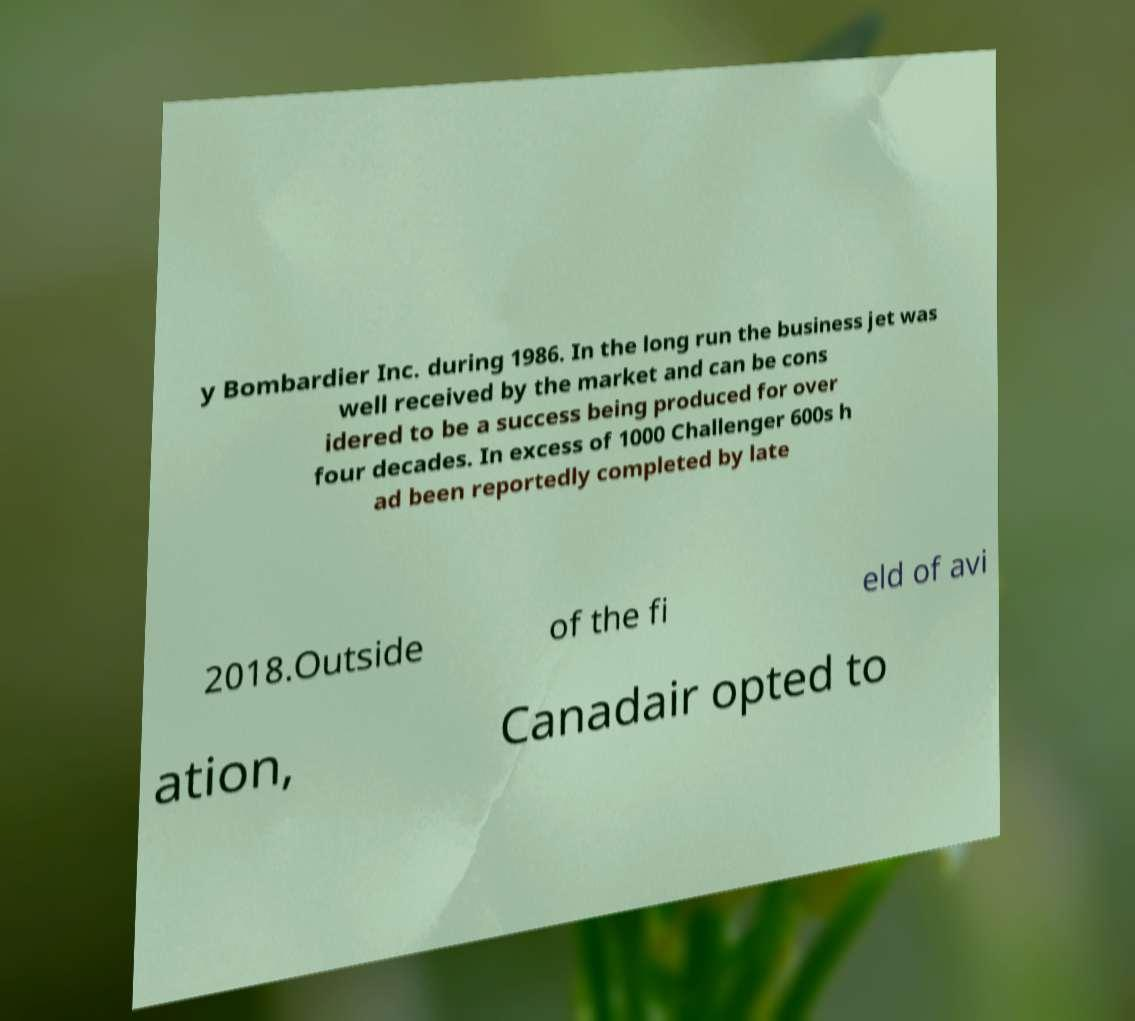I need the written content from this picture converted into text. Can you do that? y Bombardier Inc. during 1986. In the long run the business jet was well received by the market and can be cons idered to be a success being produced for over four decades. In excess of 1000 Challenger 600s h ad been reportedly completed by late 2018.Outside of the fi eld of avi ation, Canadair opted to 